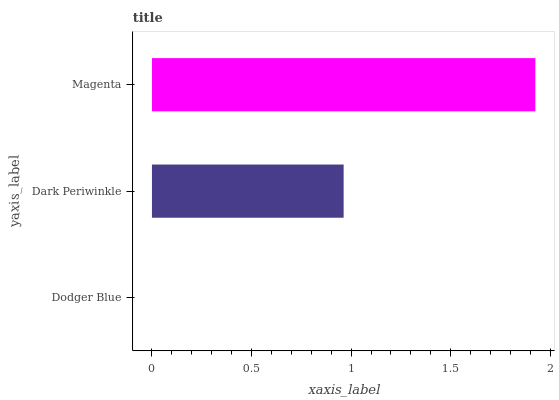Is Dodger Blue the minimum?
Answer yes or no. Yes. Is Magenta the maximum?
Answer yes or no. Yes. Is Dark Periwinkle the minimum?
Answer yes or no. No. Is Dark Periwinkle the maximum?
Answer yes or no. No. Is Dark Periwinkle greater than Dodger Blue?
Answer yes or no. Yes. Is Dodger Blue less than Dark Periwinkle?
Answer yes or no. Yes. Is Dodger Blue greater than Dark Periwinkle?
Answer yes or no. No. Is Dark Periwinkle less than Dodger Blue?
Answer yes or no. No. Is Dark Periwinkle the high median?
Answer yes or no. Yes. Is Dark Periwinkle the low median?
Answer yes or no. Yes. Is Dodger Blue the high median?
Answer yes or no. No. Is Dodger Blue the low median?
Answer yes or no. No. 